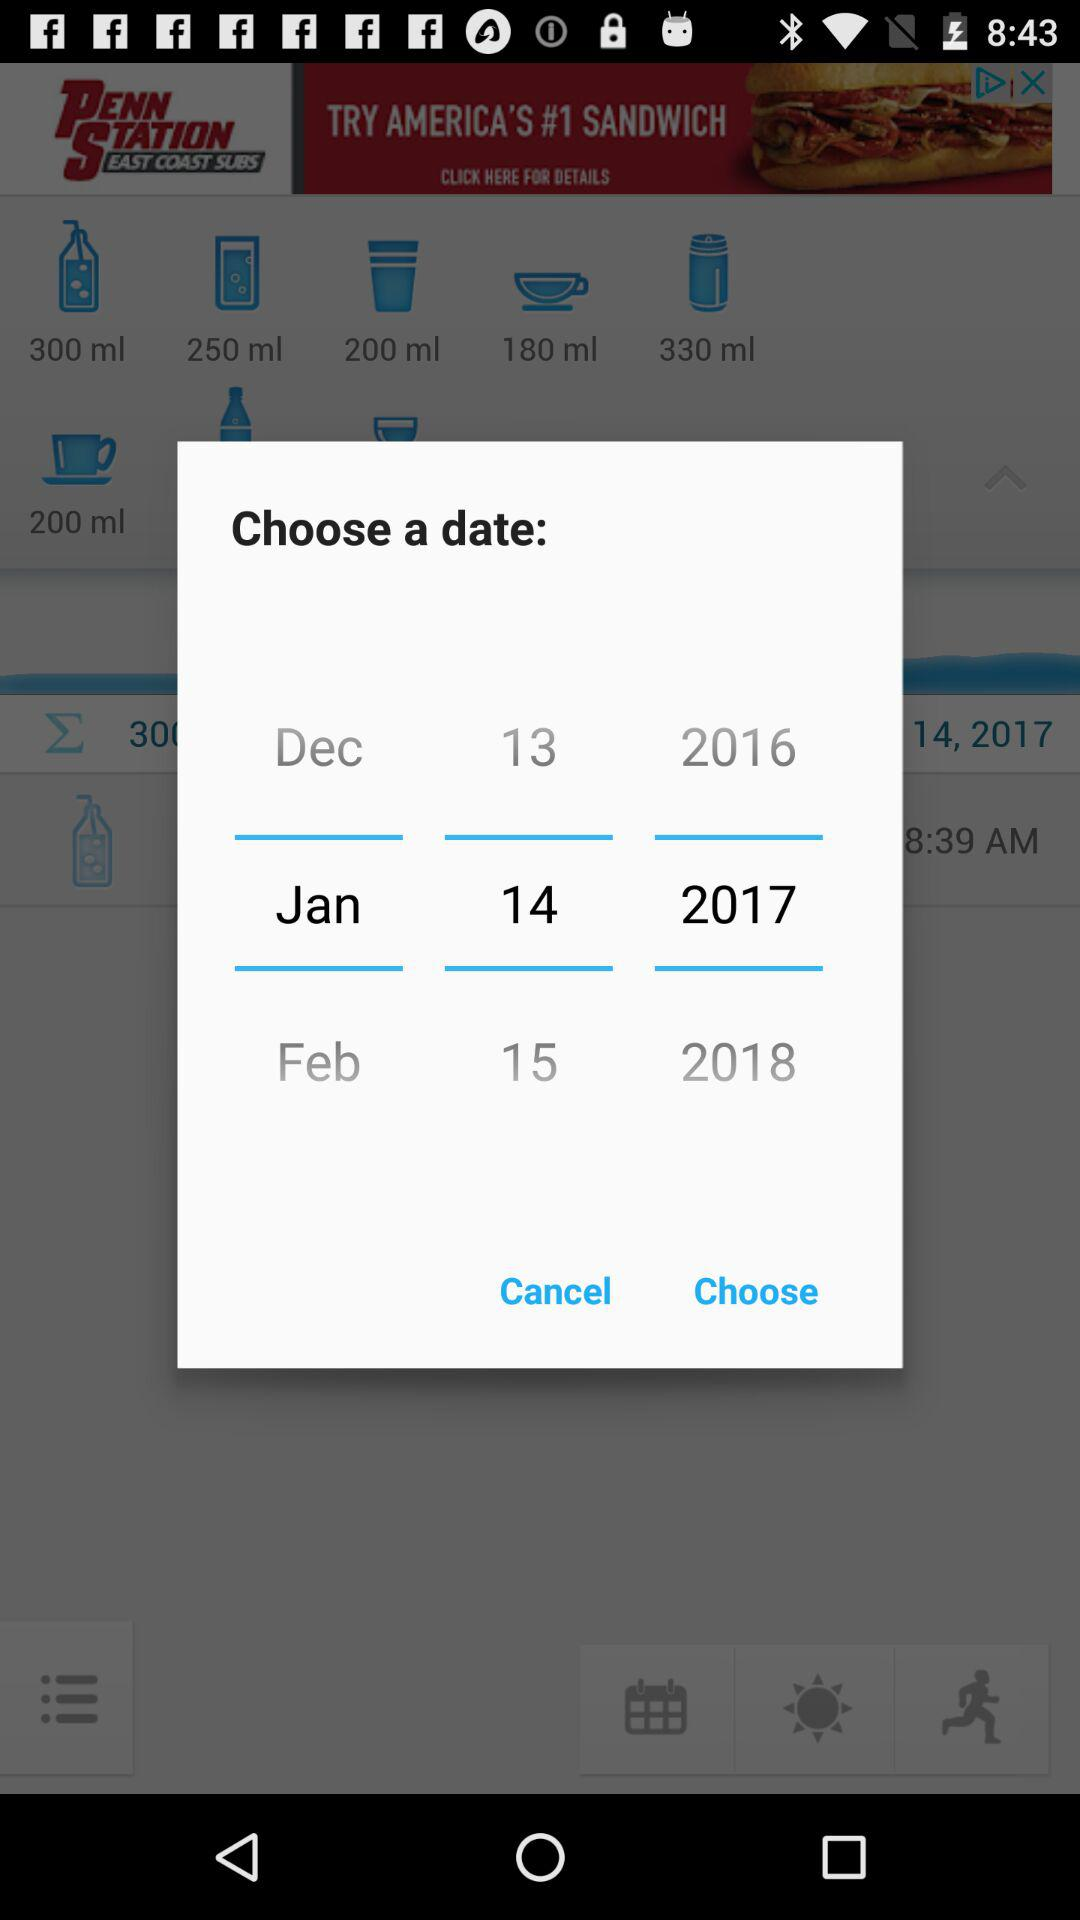What is the selected date? The selected date is January 14, 2017. 